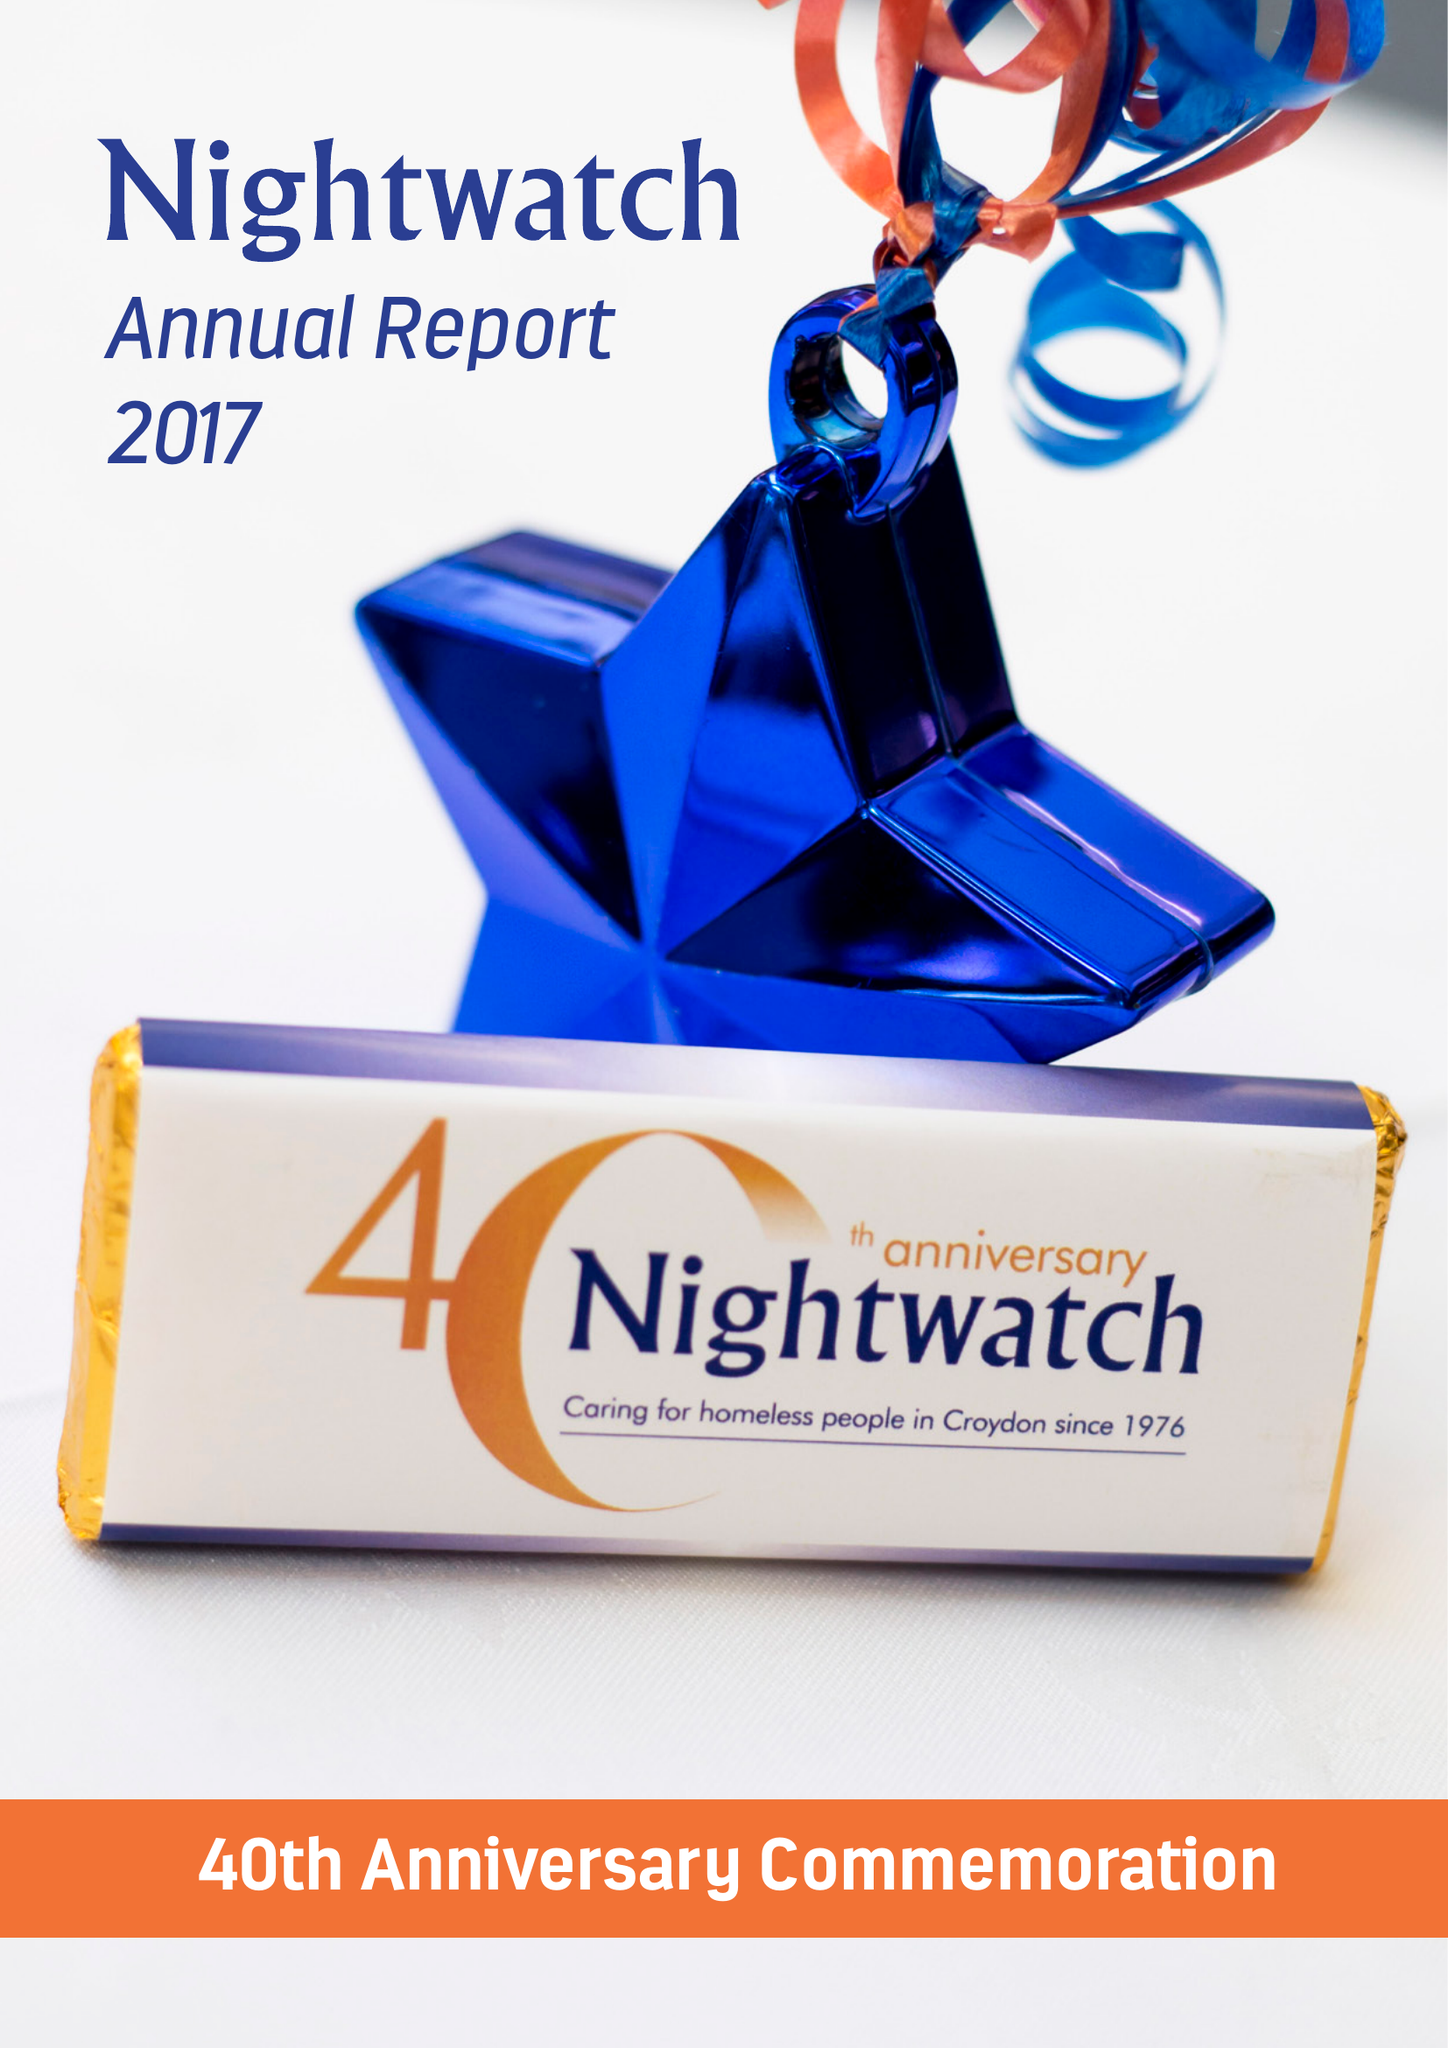What is the value for the charity_name?
Answer the question using a single word or phrase. Nightwatch 